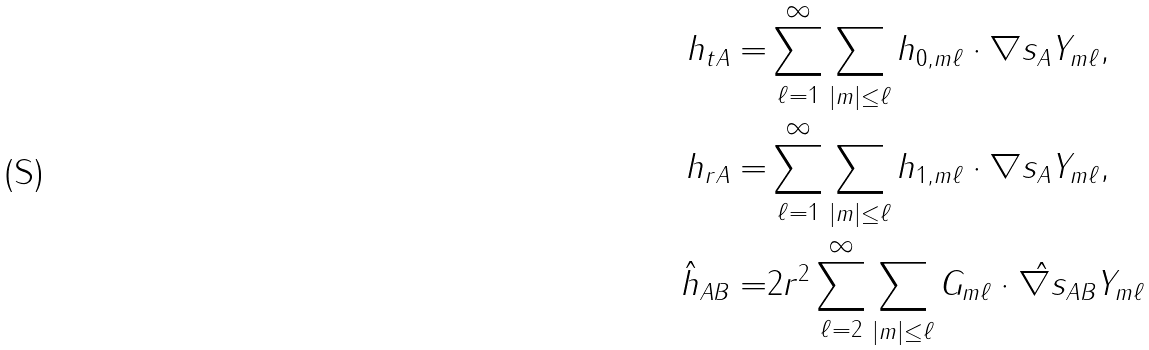<formula> <loc_0><loc_0><loc_500><loc_500>h _ { t A } = & \sum _ { \ell = 1 } ^ { \infty } \sum _ { | m | \leq \ell } h _ { 0 , m \ell } \cdot \nabla s _ { A } Y _ { m \ell } , \\ h _ { r A } = & \sum _ { \ell = 1 } ^ { \infty } \sum _ { | m | \leq \ell } h _ { 1 , m \ell } \cdot \nabla s _ { A } Y _ { m \ell } , \\ \hat { h } _ { A B } = & 2 r ^ { 2 } \sum _ { \ell = 2 } ^ { \infty } \sum _ { | m | \leq \ell } G _ { m \ell } \cdot \hat { \nabla s } _ { A B } Y _ { m \ell }</formula> 